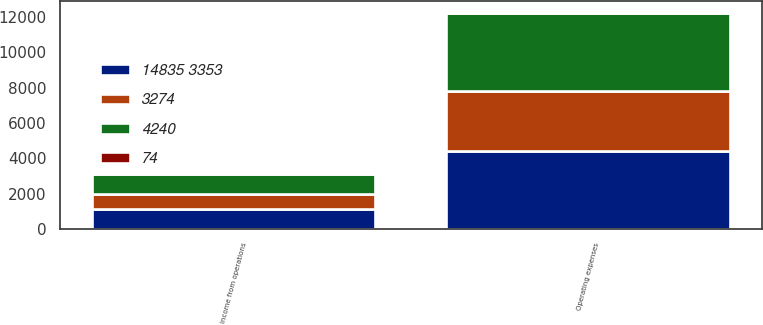Convert chart to OTSL. <chart><loc_0><loc_0><loc_500><loc_500><stacked_bar_chart><ecel><fcel>Operating expenses<fcel>Income from operations<nl><fcel>4240<fcel>4435<fcel>1170<nl><fcel>74<fcel>33<fcel>41<nl><fcel>14835 3353<fcel>4402<fcel>1129<nl><fcel>3274<fcel>3408<fcel>832<nl></chart> 